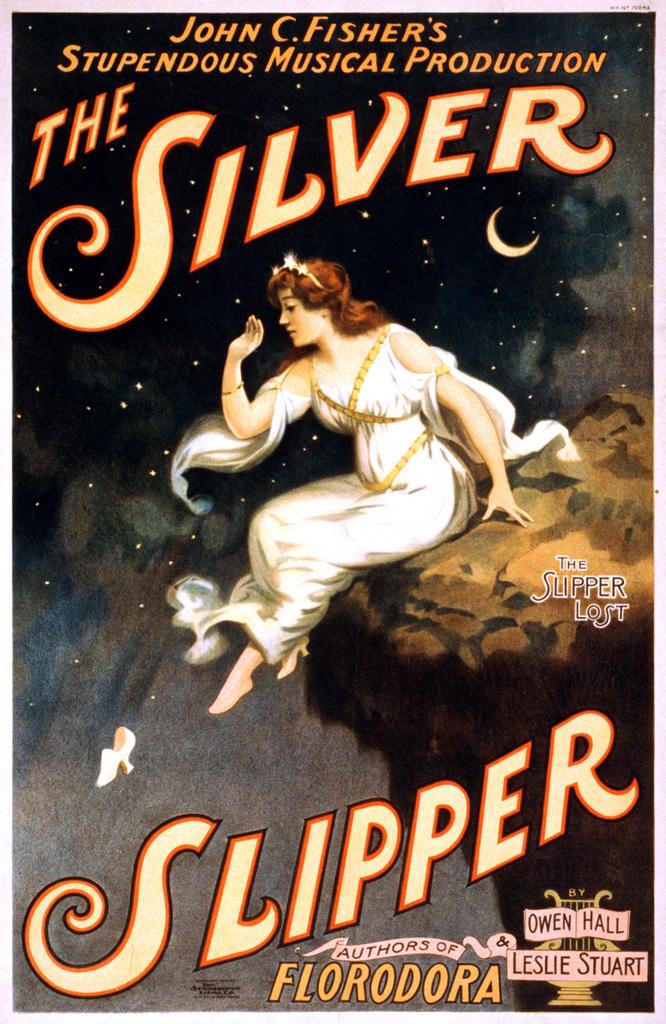Who made this production?
Provide a short and direct response. John c. fisher. What type of production is this?
Your answer should be compact. Musical. 